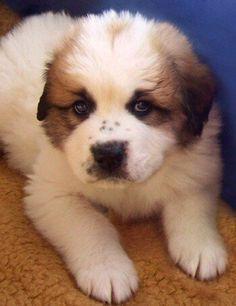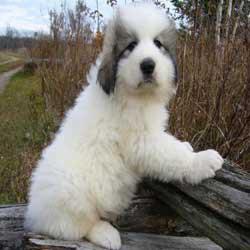The first image is the image on the left, the second image is the image on the right. Given the left and right images, does the statement "There is two dogs in the left image." hold true? Answer yes or no. No. The first image is the image on the left, the second image is the image on the right. Given the left and right images, does the statement "Each image contains one fluffy young dog in a non-standing position, and all dogs are white with darker fur on their ears and around their eyes." hold true? Answer yes or no. Yes. 